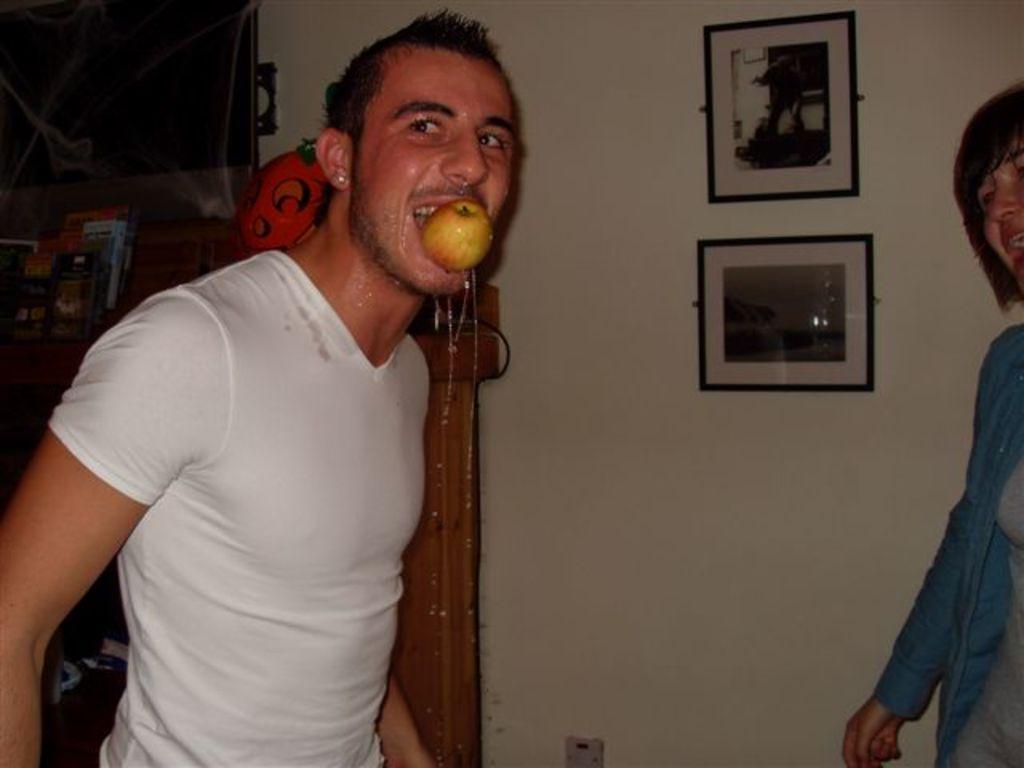How would you summarize this image in a sentence or two? In this image there is a man in the middle who kept an apple in his mouth. There is water falling down from his face. On the right side there is a woman. In the background there is a wall on which there are two photo frames. On the left side there is a banner. In front of the banner there are racks on which there are books. 